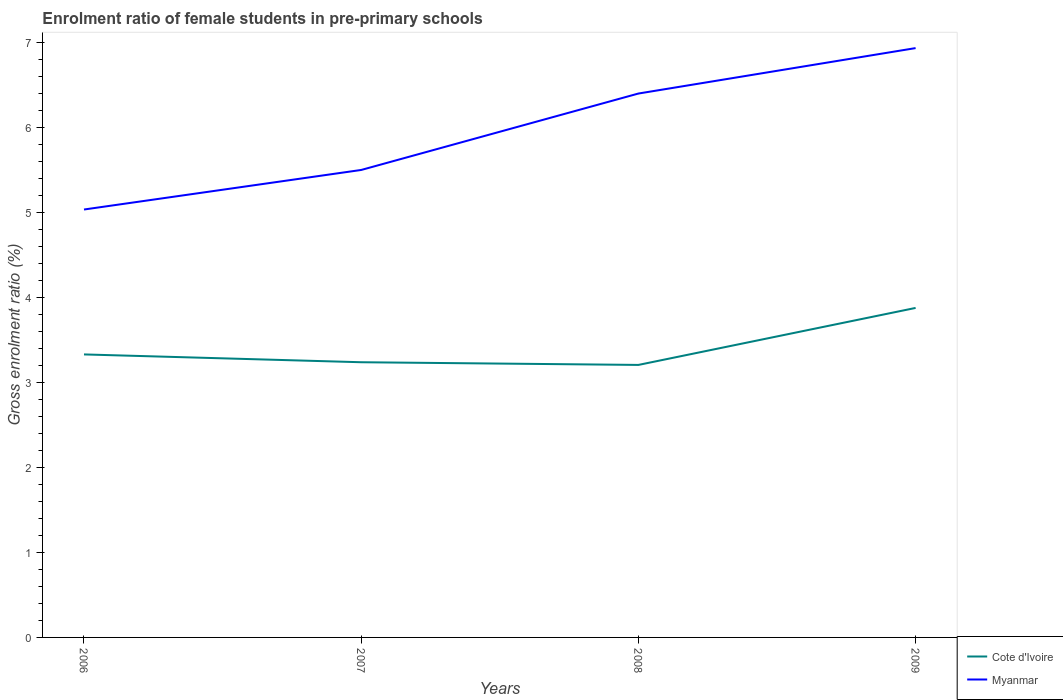How many different coloured lines are there?
Offer a terse response. 2. Does the line corresponding to Cote d'Ivoire intersect with the line corresponding to Myanmar?
Ensure brevity in your answer.  No. Is the number of lines equal to the number of legend labels?
Give a very brief answer. Yes. Across all years, what is the maximum enrolment ratio of female students in pre-primary schools in Myanmar?
Ensure brevity in your answer.  5.03. What is the total enrolment ratio of female students in pre-primary schools in Cote d'Ivoire in the graph?
Give a very brief answer. 0.12. What is the difference between the highest and the second highest enrolment ratio of female students in pre-primary schools in Cote d'Ivoire?
Ensure brevity in your answer.  0.67. Are the values on the major ticks of Y-axis written in scientific E-notation?
Provide a succinct answer. No. Does the graph contain grids?
Provide a short and direct response. No. Where does the legend appear in the graph?
Keep it short and to the point. Bottom right. How are the legend labels stacked?
Your answer should be compact. Vertical. What is the title of the graph?
Your answer should be very brief. Enrolment ratio of female students in pre-primary schools. What is the label or title of the Y-axis?
Keep it short and to the point. Gross enrolment ratio (%). What is the Gross enrolment ratio (%) of Cote d'Ivoire in 2006?
Provide a succinct answer. 3.33. What is the Gross enrolment ratio (%) of Myanmar in 2006?
Your response must be concise. 5.03. What is the Gross enrolment ratio (%) in Cote d'Ivoire in 2007?
Give a very brief answer. 3.24. What is the Gross enrolment ratio (%) in Myanmar in 2007?
Your answer should be very brief. 5.5. What is the Gross enrolment ratio (%) of Cote d'Ivoire in 2008?
Provide a succinct answer. 3.21. What is the Gross enrolment ratio (%) in Myanmar in 2008?
Your response must be concise. 6.4. What is the Gross enrolment ratio (%) of Cote d'Ivoire in 2009?
Your response must be concise. 3.88. What is the Gross enrolment ratio (%) in Myanmar in 2009?
Provide a short and direct response. 6.93. Across all years, what is the maximum Gross enrolment ratio (%) of Cote d'Ivoire?
Keep it short and to the point. 3.88. Across all years, what is the maximum Gross enrolment ratio (%) of Myanmar?
Make the answer very short. 6.93. Across all years, what is the minimum Gross enrolment ratio (%) in Cote d'Ivoire?
Keep it short and to the point. 3.21. Across all years, what is the minimum Gross enrolment ratio (%) in Myanmar?
Offer a very short reply. 5.03. What is the total Gross enrolment ratio (%) of Cote d'Ivoire in the graph?
Your answer should be very brief. 13.65. What is the total Gross enrolment ratio (%) of Myanmar in the graph?
Your response must be concise. 23.86. What is the difference between the Gross enrolment ratio (%) in Cote d'Ivoire in 2006 and that in 2007?
Your response must be concise. 0.09. What is the difference between the Gross enrolment ratio (%) of Myanmar in 2006 and that in 2007?
Your response must be concise. -0.47. What is the difference between the Gross enrolment ratio (%) of Cote d'Ivoire in 2006 and that in 2008?
Provide a short and direct response. 0.12. What is the difference between the Gross enrolment ratio (%) in Myanmar in 2006 and that in 2008?
Keep it short and to the point. -1.36. What is the difference between the Gross enrolment ratio (%) in Cote d'Ivoire in 2006 and that in 2009?
Make the answer very short. -0.55. What is the difference between the Gross enrolment ratio (%) of Myanmar in 2006 and that in 2009?
Give a very brief answer. -1.9. What is the difference between the Gross enrolment ratio (%) of Cote d'Ivoire in 2007 and that in 2008?
Make the answer very short. 0.03. What is the difference between the Gross enrolment ratio (%) in Myanmar in 2007 and that in 2008?
Ensure brevity in your answer.  -0.9. What is the difference between the Gross enrolment ratio (%) in Cote d'Ivoire in 2007 and that in 2009?
Make the answer very short. -0.64. What is the difference between the Gross enrolment ratio (%) of Myanmar in 2007 and that in 2009?
Provide a succinct answer. -1.43. What is the difference between the Gross enrolment ratio (%) of Cote d'Ivoire in 2008 and that in 2009?
Your answer should be compact. -0.67. What is the difference between the Gross enrolment ratio (%) in Myanmar in 2008 and that in 2009?
Offer a very short reply. -0.53. What is the difference between the Gross enrolment ratio (%) in Cote d'Ivoire in 2006 and the Gross enrolment ratio (%) in Myanmar in 2007?
Keep it short and to the point. -2.17. What is the difference between the Gross enrolment ratio (%) in Cote d'Ivoire in 2006 and the Gross enrolment ratio (%) in Myanmar in 2008?
Your answer should be compact. -3.07. What is the difference between the Gross enrolment ratio (%) of Cote d'Ivoire in 2006 and the Gross enrolment ratio (%) of Myanmar in 2009?
Give a very brief answer. -3.6. What is the difference between the Gross enrolment ratio (%) of Cote d'Ivoire in 2007 and the Gross enrolment ratio (%) of Myanmar in 2008?
Make the answer very short. -3.16. What is the difference between the Gross enrolment ratio (%) of Cote d'Ivoire in 2007 and the Gross enrolment ratio (%) of Myanmar in 2009?
Provide a short and direct response. -3.7. What is the difference between the Gross enrolment ratio (%) in Cote d'Ivoire in 2008 and the Gross enrolment ratio (%) in Myanmar in 2009?
Your answer should be very brief. -3.73. What is the average Gross enrolment ratio (%) in Cote d'Ivoire per year?
Provide a short and direct response. 3.41. What is the average Gross enrolment ratio (%) of Myanmar per year?
Give a very brief answer. 5.97. In the year 2006, what is the difference between the Gross enrolment ratio (%) in Cote d'Ivoire and Gross enrolment ratio (%) in Myanmar?
Your answer should be compact. -1.7. In the year 2007, what is the difference between the Gross enrolment ratio (%) in Cote d'Ivoire and Gross enrolment ratio (%) in Myanmar?
Give a very brief answer. -2.26. In the year 2008, what is the difference between the Gross enrolment ratio (%) of Cote d'Ivoire and Gross enrolment ratio (%) of Myanmar?
Ensure brevity in your answer.  -3.19. In the year 2009, what is the difference between the Gross enrolment ratio (%) in Cote d'Ivoire and Gross enrolment ratio (%) in Myanmar?
Provide a short and direct response. -3.06. What is the ratio of the Gross enrolment ratio (%) of Cote d'Ivoire in 2006 to that in 2007?
Provide a succinct answer. 1.03. What is the ratio of the Gross enrolment ratio (%) in Myanmar in 2006 to that in 2007?
Offer a very short reply. 0.92. What is the ratio of the Gross enrolment ratio (%) of Cote d'Ivoire in 2006 to that in 2008?
Your answer should be very brief. 1.04. What is the ratio of the Gross enrolment ratio (%) of Myanmar in 2006 to that in 2008?
Keep it short and to the point. 0.79. What is the ratio of the Gross enrolment ratio (%) in Cote d'Ivoire in 2006 to that in 2009?
Make the answer very short. 0.86. What is the ratio of the Gross enrolment ratio (%) in Myanmar in 2006 to that in 2009?
Offer a terse response. 0.73. What is the ratio of the Gross enrolment ratio (%) in Cote d'Ivoire in 2007 to that in 2008?
Make the answer very short. 1.01. What is the ratio of the Gross enrolment ratio (%) in Myanmar in 2007 to that in 2008?
Provide a succinct answer. 0.86. What is the ratio of the Gross enrolment ratio (%) of Cote d'Ivoire in 2007 to that in 2009?
Provide a short and direct response. 0.84. What is the ratio of the Gross enrolment ratio (%) of Myanmar in 2007 to that in 2009?
Provide a short and direct response. 0.79. What is the ratio of the Gross enrolment ratio (%) of Cote d'Ivoire in 2008 to that in 2009?
Give a very brief answer. 0.83. What is the ratio of the Gross enrolment ratio (%) of Myanmar in 2008 to that in 2009?
Keep it short and to the point. 0.92. What is the difference between the highest and the second highest Gross enrolment ratio (%) in Cote d'Ivoire?
Make the answer very short. 0.55. What is the difference between the highest and the second highest Gross enrolment ratio (%) of Myanmar?
Offer a very short reply. 0.53. What is the difference between the highest and the lowest Gross enrolment ratio (%) of Cote d'Ivoire?
Make the answer very short. 0.67. What is the difference between the highest and the lowest Gross enrolment ratio (%) of Myanmar?
Offer a terse response. 1.9. 